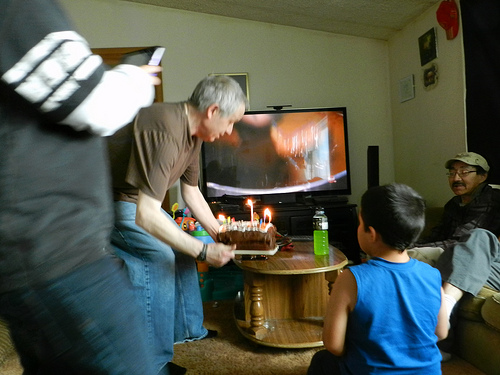What is the occasion being celebrated in the image? The occasion appears to be a birthday celebration, suggested by the lit candles on the cake in the center of the room, with attention focused on the person preparing to blow them out. 